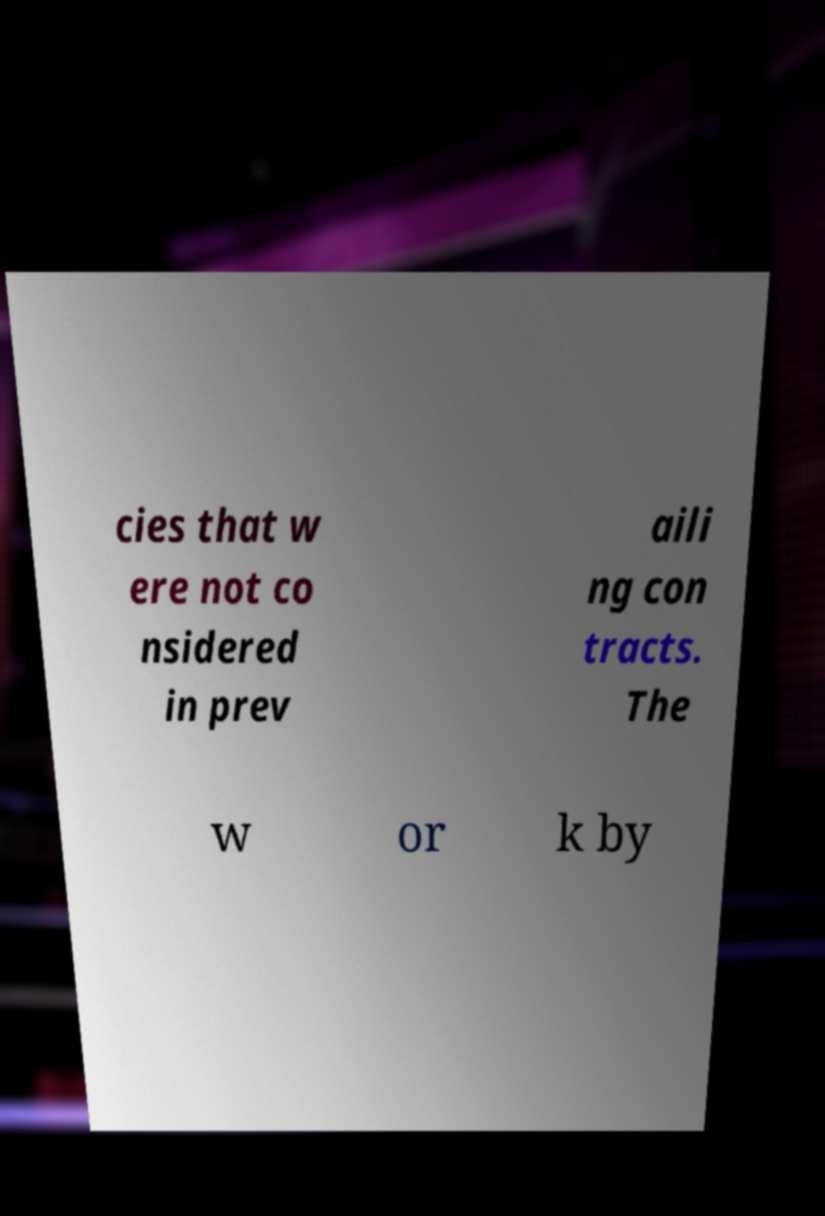Please read and relay the text visible in this image. What does it say? cies that w ere not co nsidered in prev aili ng con tracts. The w or k by 